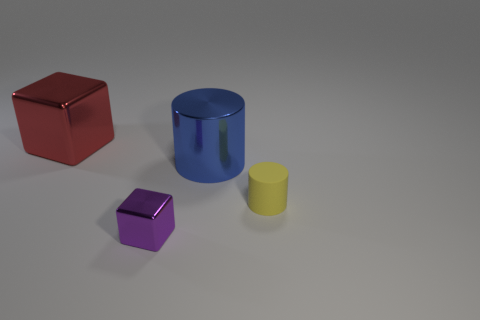Add 3 big yellow cylinders. How many objects exist? 7 Subtract 1 red cubes. How many objects are left? 3 Subtract all blue cylinders. Subtract all brown blocks. How many cylinders are left? 1 Subtract all big blue cylinders. Subtract all tiny yellow rubber cylinders. How many objects are left? 2 Add 2 large blue cylinders. How many large blue cylinders are left? 3 Add 4 small gray metal balls. How many small gray metal balls exist? 4 